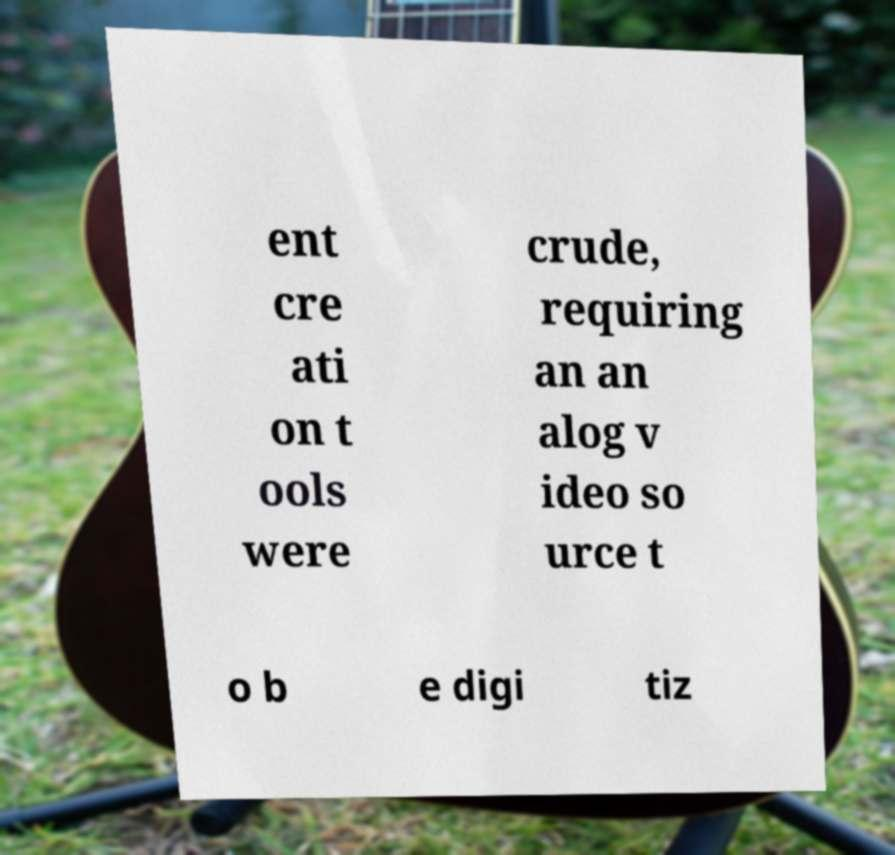Please read and relay the text visible in this image. What does it say? ent cre ati on t ools were crude, requiring an an alog v ideo so urce t o b e digi tiz 